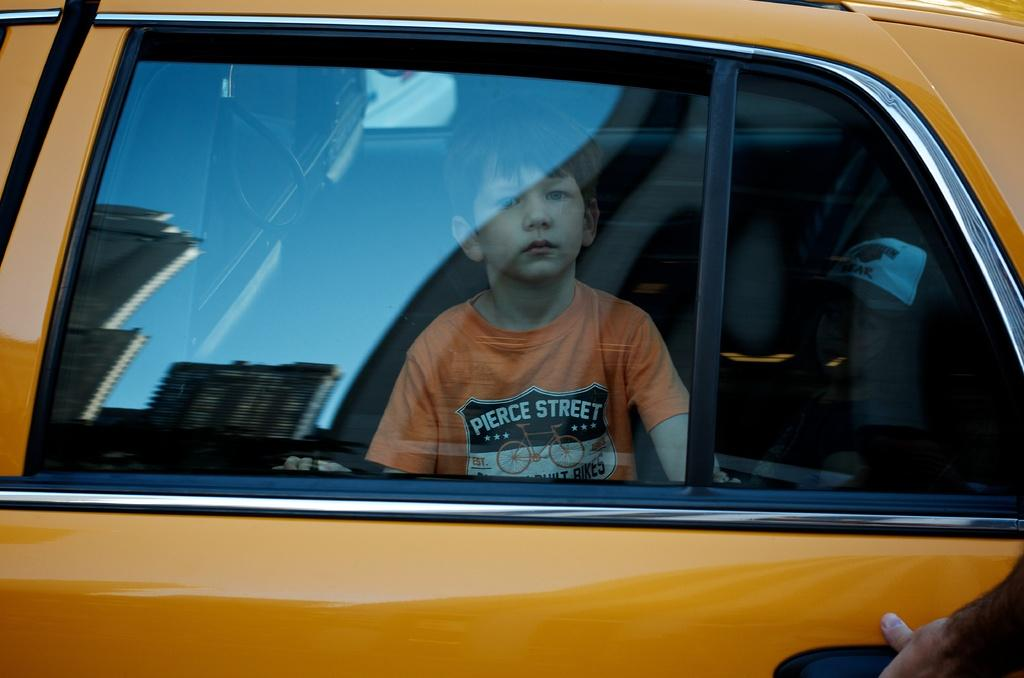<image>
Write a terse but informative summary of the picture. The kids orange shirt says Pierce Street on it 